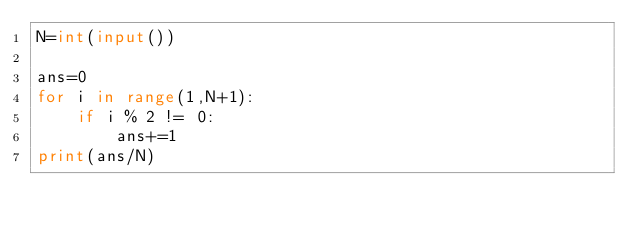<code> <loc_0><loc_0><loc_500><loc_500><_Python_>N=int(input())

ans=0
for i in range(1,N+1):
    if i % 2 != 0:
        ans+=1
print(ans/N)
    </code> 